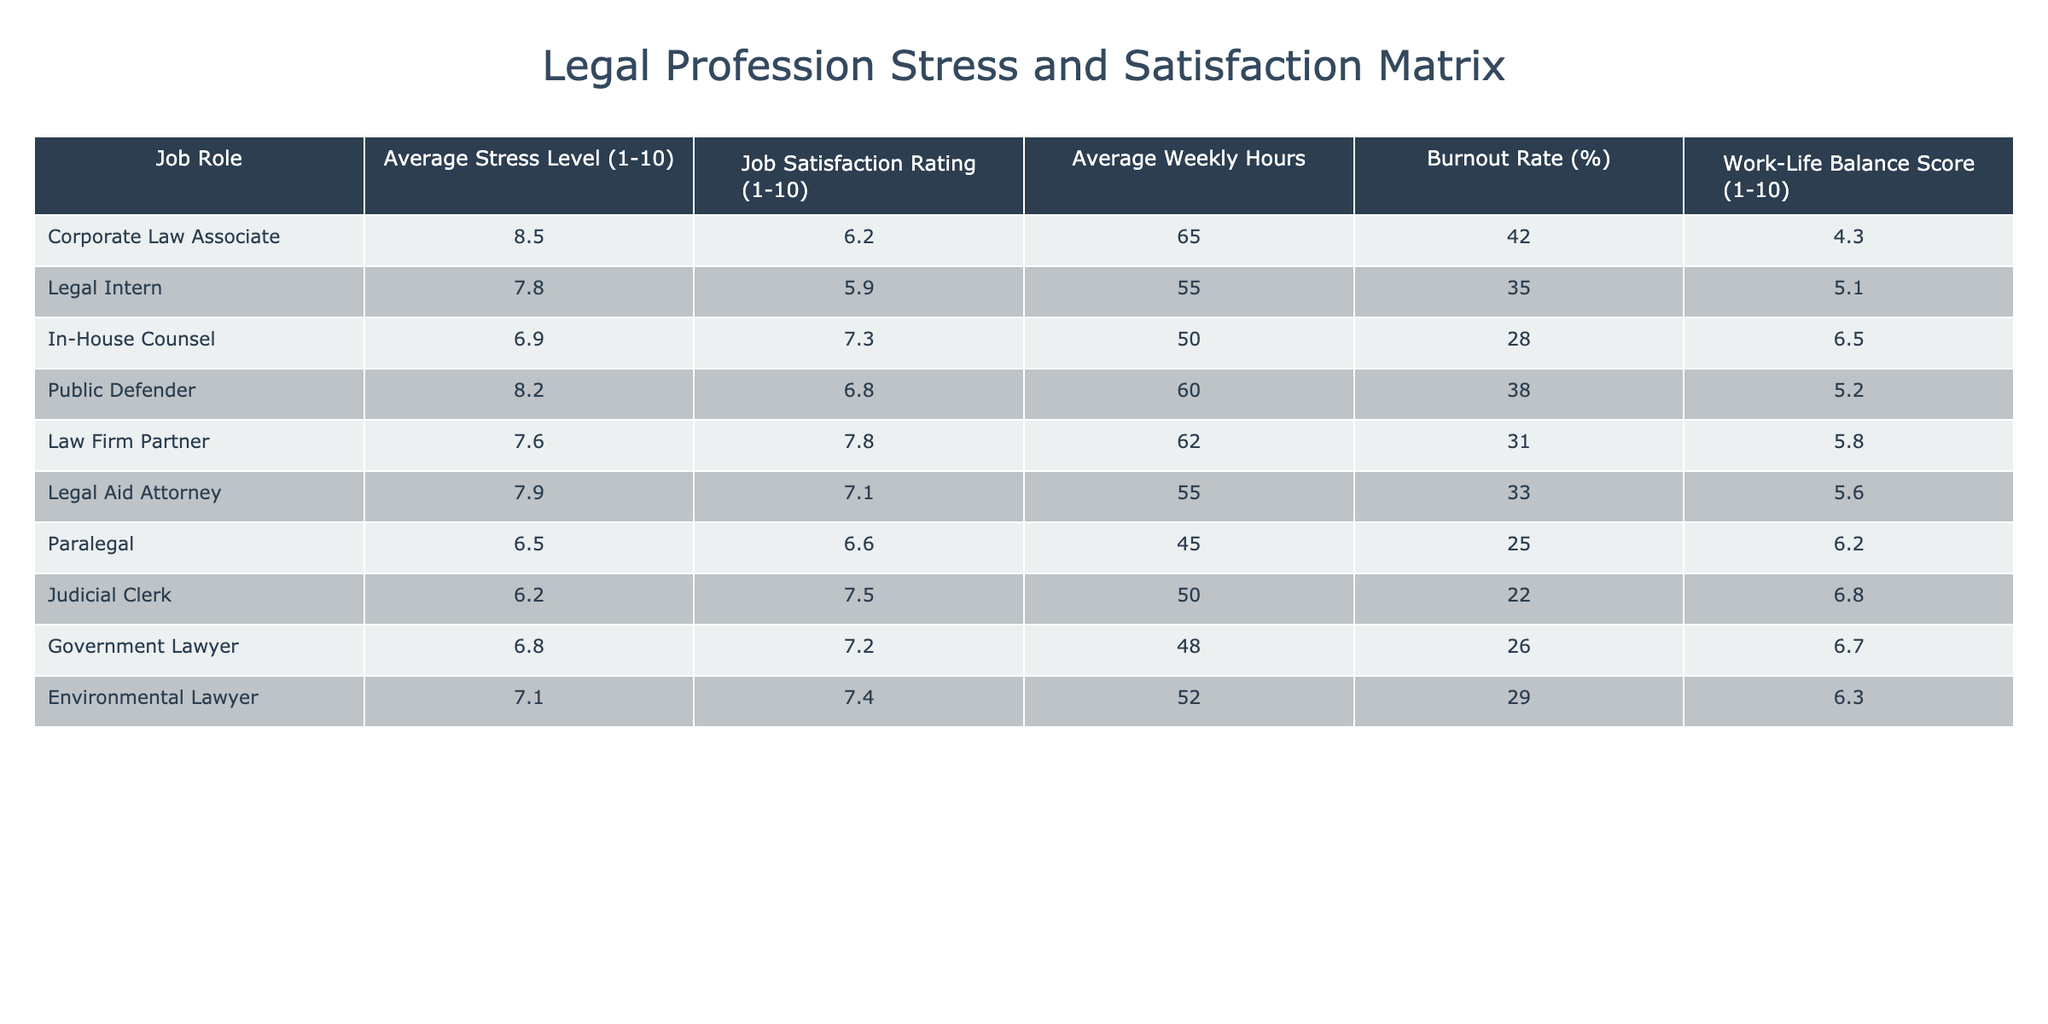What is the average stress level for a Corporate Law Associate? The table shows that the average stress level for Corporate Law Associates is listed as 8.5.
Answer: 8.5 Which job role has the highest job satisfaction rating? By looking at the job satisfaction ratings in the table, the role with the highest rating is Law Firm Partner, with a rating of 7.8.
Answer: Law Firm Partner What is the burnout rate for Public Defenders? The table lists the burnout rate for Public Defenders as 38%.
Answer: 38% Calculate the average weekly hours for all roles combined. Adding all the average weekly hours (65 + 55 + 50 + 60 + 62 + 55 + 45 + 50 + 48 + 52 =  542) and dividing by the number of roles (10) results in an average of 54.2.
Answer: 54.2 Is the work-life balance score higher for In-House Counsel or for Judicial Clerks? The work-life balance score for In-House Counsel is 6.5 and for Judicial Clerks is 6.8. Since 6.8 > 6.5, Judicial Clerks have a higher score.
Answer: Judicial Clerks What is the difference in average stress levels between Legal Interns and Paralegals? Taking the average stress level for Legal Interns (7.8) and subtracting the average for Paralegals (6.5) gives a difference of 7.8 - 6.5 = 1.3.
Answer: 1.3 Which job role has the lowest average stress level? Looking at the average stress levels, the lowest is for Paralegals at 6.5.
Answer: Paralegals If we average the job satisfaction ratings of Environmental Lawyers and Government Lawyers, what do we get? The job satisfaction ratings are 7.4 for Environmental Lawyers and 7.2 for Government Lawyers. The average is (7.4 + 7.2)/2 = 7.3.
Answer: 7.3 Are the average weekly hours for Legal Aid Attorneys less than the average for In-House Counsel? Legal Aid Attorneys have 55 hours, while In-House Counsel has 50 hours. Since 55 > 50, the statement is false.
Answer: No Which job role has a stress level lower than 7? The roles with stress levels below 7 are In-House Counsel (6.9), Paralegal (6.5), and Judicial Clerk (6.2).
Answer: In-House Counsel, Paralegal, Judicial Clerk What is the work-life balance score of the job role with the highest burnout rate? The job role with the highest burnout rate is Corporate Law Associate (42%), and its work-life balance score is 4.3.
Answer: 4.3 